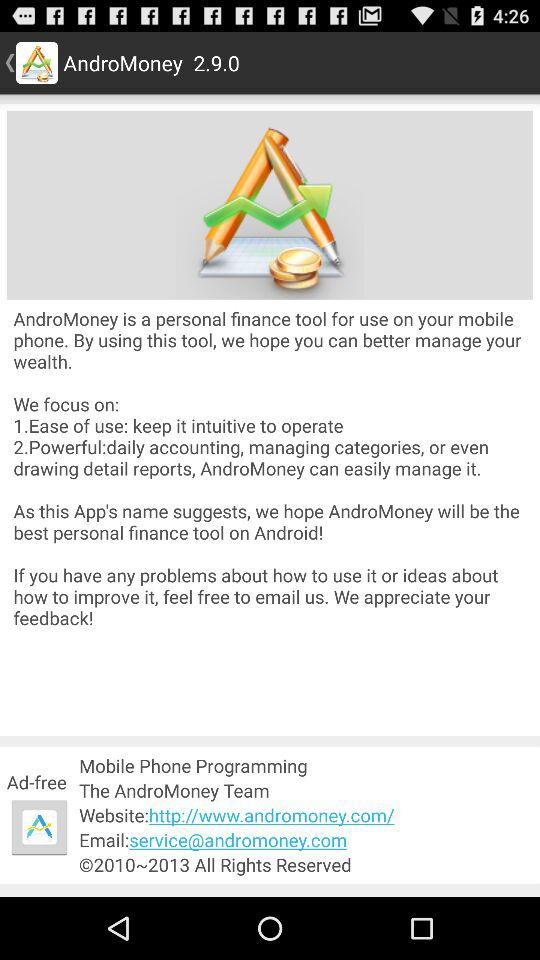What is the email address of "AndroMoney"? The email address is service@andromoney.com. 